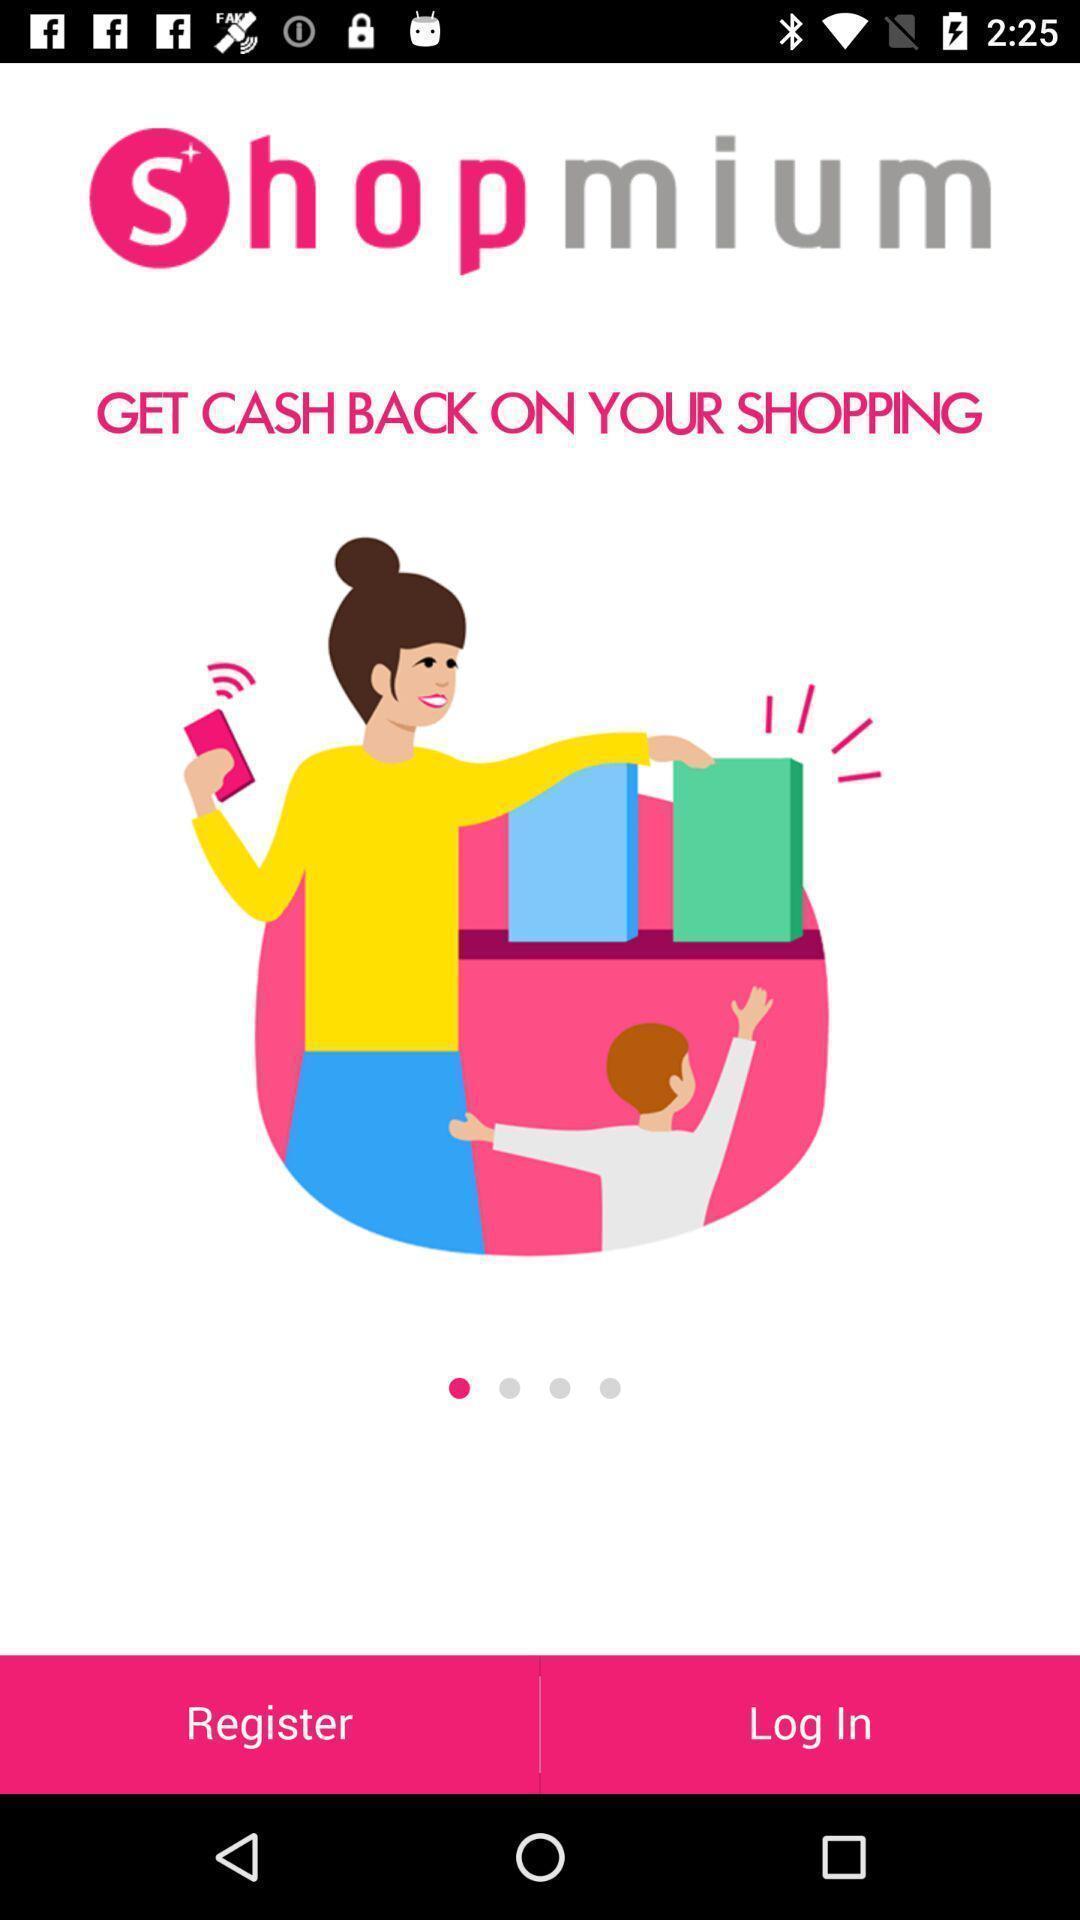Explain what's happening in this screen capture. Page with register and login option. 